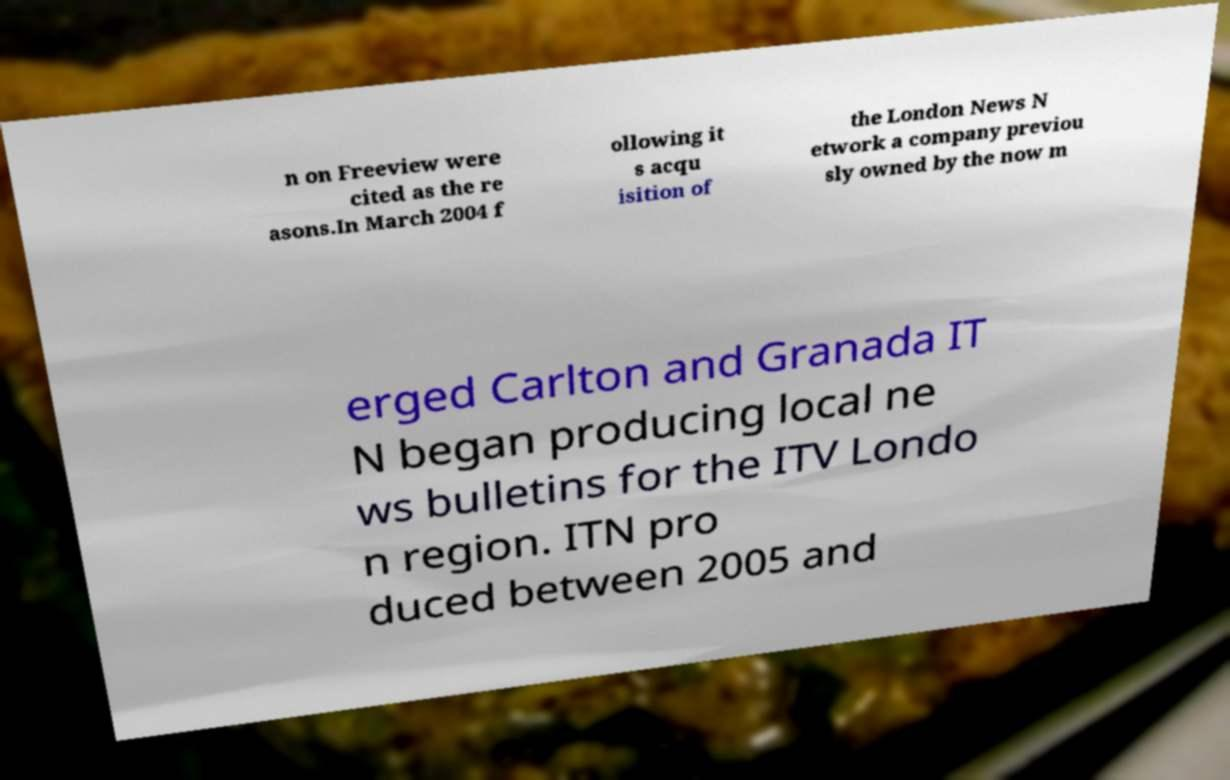Could you assist in decoding the text presented in this image and type it out clearly? n on Freeview were cited as the re asons.In March 2004 f ollowing it s acqu isition of the London News N etwork a company previou sly owned by the now m erged Carlton and Granada IT N began producing local ne ws bulletins for the ITV Londo n region. ITN pro duced between 2005 and 